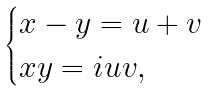<formula> <loc_0><loc_0><loc_500><loc_500>\begin{cases} x - y = u + v \\ x y = i u v , \end{cases}</formula> 